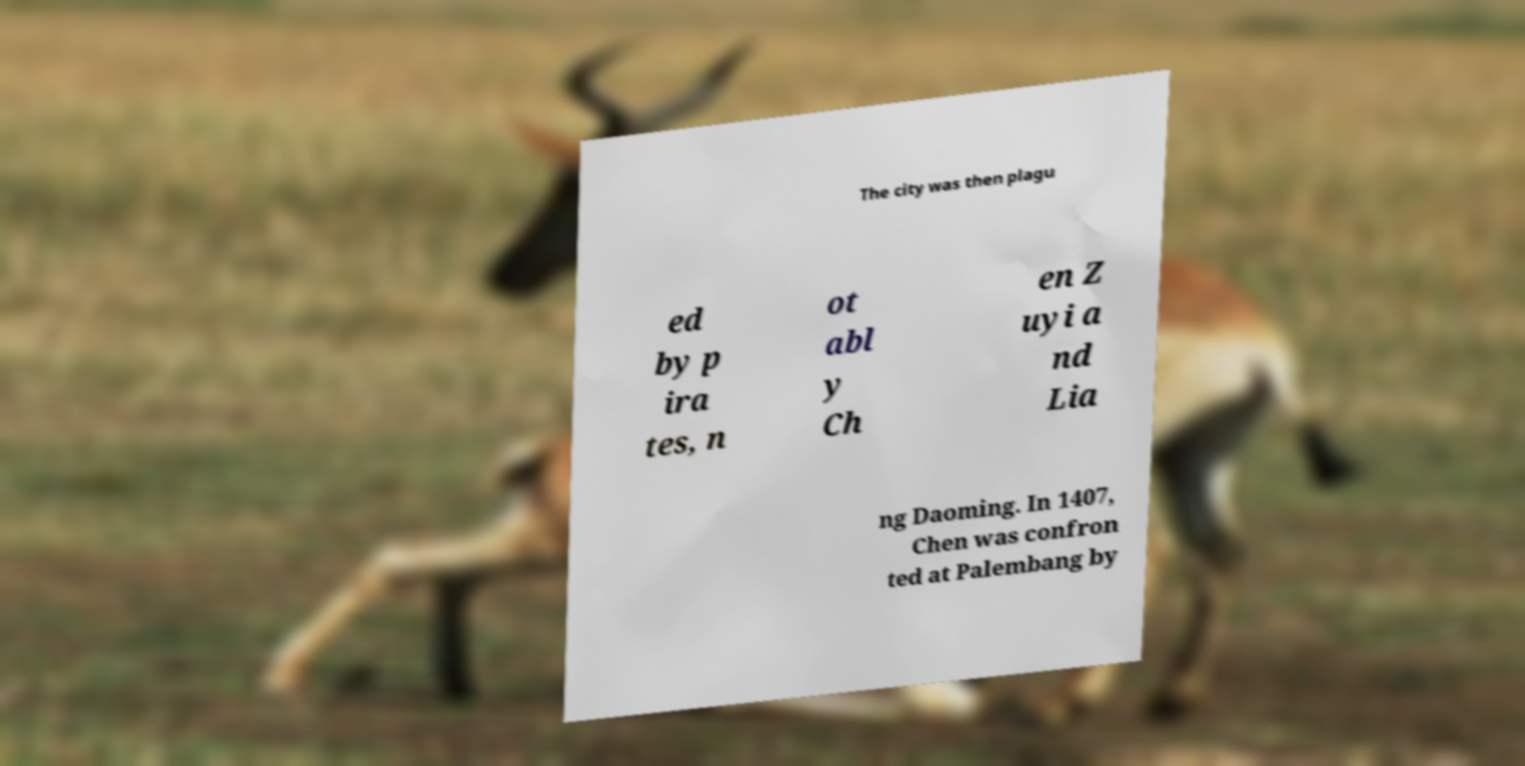For documentation purposes, I need the text within this image transcribed. Could you provide that? The city was then plagu ed by p ira tes, n ot abl y Ch en Z uyi a nd Lia ng Daoming. In 1407, Chen was confron ted at Palembang by 